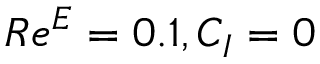<formula> <loc_0><loc_0><loc_500><loc_500>R e ^ { E } = 0 . 1 , C _ { I } = 0</formula> 